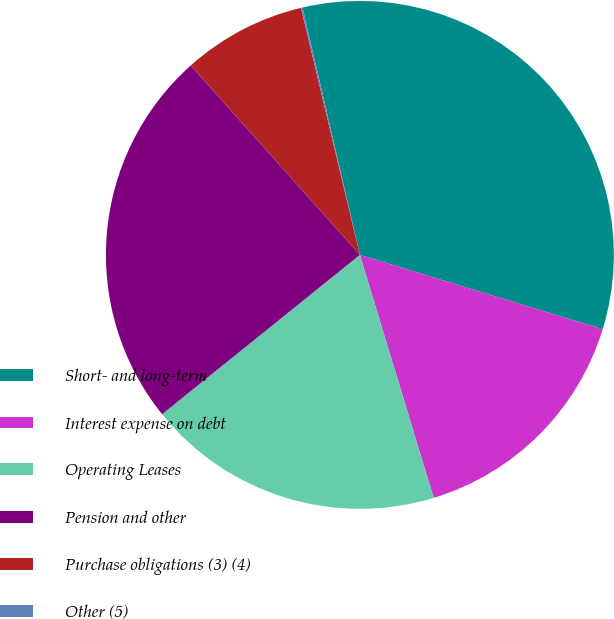Convert chart to OTSL. <chart><loc_0><loc_0><loc_500><loc_500><pie_chart><fcel>Short- and long-term<fcel>Interest expense on debt<fcel>Operating Leases<fcel>Pension and other<fcel>Purchase obligations (3) (4)<fcel>Other (5)<nl><fcel>33.36%<fcel>15.58%<fcel>18.9%<fcel>24.19%<fcel>7.88%<fcel>0.1%<nl></chart> 